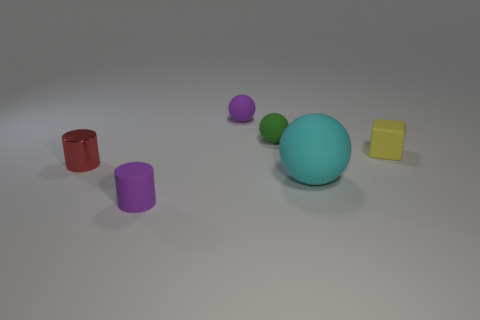Is there anything else that is the same shape as the yellow object?
Ensure brevity in your answer.  No. What number of big rubber objects are left of the tiny thing that is on the left side of the tiny cylinder in front of the small red cylinder?
Your answer should be very brief. 0. There is a green object that is the same shape as the cyan matte object; what material is it?
Ensure brevity in your answer.  Rubber. What is the material of the tiny object that is both to the right of the tiny purple cylinder and on the left side of the green thing?
Give a very brief answer. Rubber. Is the number of large cyan spheres that are on the right side of the purple cylinder less than the number of purple matte things that are left of the large thing?
Your answer should be very brief. Yes. What number of other objects are there of the same size as the matte cube?
Your answer should be very brief. 4. There is a small purple rubber object that is right of the matte thing to the left of the small purple rubber thing that is behind the small yellow rubber object; what shape is it?
Your answer should be very brief. Sphere. What number of gray things are either large balls or shiny cylinders?
Provide a succinct answer. 0. There is a small purple thing that is in front of the small yellow thing; what number of purple things are to the left of it?
Your answer should be compact. 0. Are there any other things that are the same color as the block?
Offer a terse response. No. 